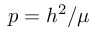<formula> <loc_0><loc_0><loc_500><loc_500>p = h ^ { 2 } / \mu</formula> 